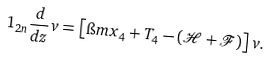<formula> <loc_0><loc_0><loc_500><loc_500>1 _ { 2 n } \frac { d } { d z } v = \left [ \i m x _ { 4 } + T _ { 4 } - ( \mathcal { H } + \mathcal { F } ) \right ] v .</formula> 